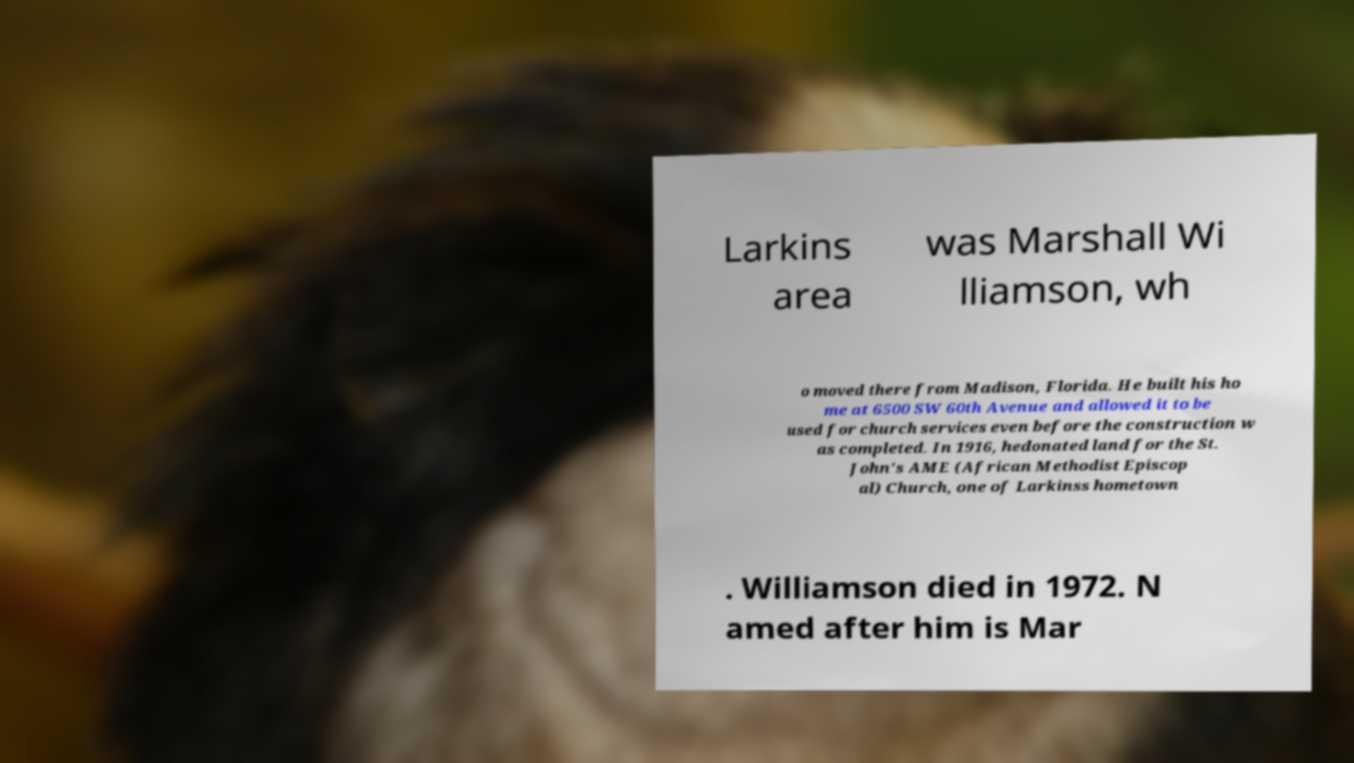What messages or text are displayed in this image? I need them in a readable, typed format. Larkins area was Marshall Wi lliamson, wh o moved there from Madison, Florida. He built his ho me at 6500 SW 60th Avenue and allowed it to be used for church services even before the construction w as completed. In 1916, hedonated land for the St. John's AME (African Methodist Episcop al) Church, one of Larkinss hometown . Williamson died in 1972. N amed after him is Mar 